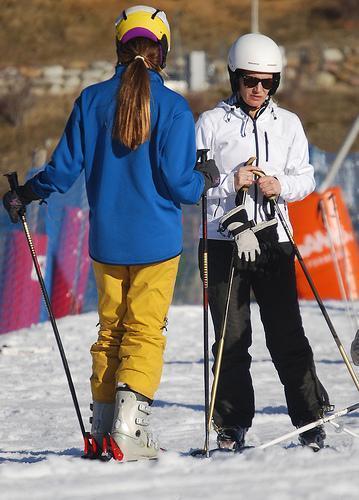How many people are there?
Give a very brief answer. 2. How many skiers are wearing yellow pants?
Give a very brief answer. 1. 